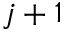<formula> <loc_0><loc_0><loc_500><loc_500>j + 1</formula> 